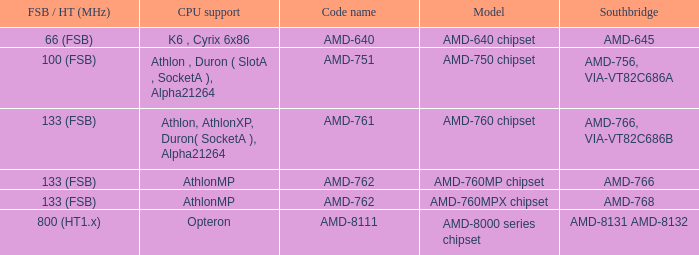What is the code name when the FSB / HT (MHz) is 100 (fsb)? AMD-751. 